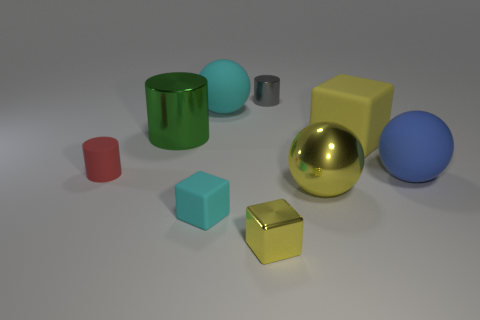There is a large ball that is both behind the yellow shiny ball and on the left side of the large yellow rubber thing; what is its color? cyan 